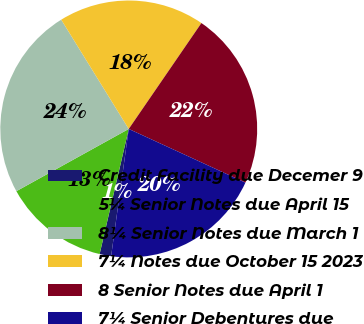<chart> <loc_0><loc_0><loc_500><loc_500><pie_chart><fcel>Credit Facility due Decemer 9<fcel>5¼ Senior Notes due April 15<fcel>8¼ Senior Notes due March 1<fcel>7¼ Notes due October 15 2023<fcel>8 Senior Notes due April 1<fcel>7¼ Senior Debentures due<nl><fcel>1.45%<fcel>13.31%<fcel>24.24%<fcel>18.38%<fcel>22.29%<fcel>20.33%<nl></chart> 